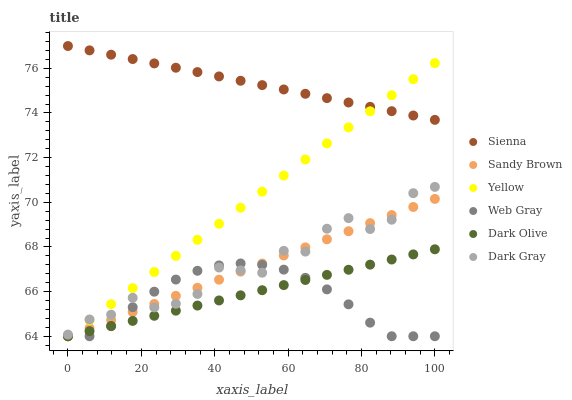Does Web Gray have the minimum area under the curve?
Answer yes or no. Yes. Does Sienna have the maximum area under the curve?
Answer yes or no. Yes. Does Dark Olive have the minimum area under the curve?
Answer yes or no. No. Does Dark Olive have the maximum area under the curve?
Answer yes or no. No. Is Sienna the smoothest?
Answer yes or no. Yes. Is Dark Gray the roughest?
Answer yes or no. Yes. Is Web Gray the smoothest?
Answer yes or no. No. Is Web Gray the roughest?
Answer yes or no. No. Does Web Gray have the lowest value?
Answer yes or no. Yes. Does Sienna have the lowest value?
Answer yes or no. No. Does Sienna have the highest value?
Answer yes or no. Yes. Does Dark Olive have the highest value?
Answer yes or no. No. Is Dark Olive less than Sienna?
Answer yes or no. Yes. Is Dark Gray greater than Dark Olive?
Answer yes or no. Yes. Does Sandy Brown intersect Web Gray?
Answer yes or no. Yes. Is Sandy Brown less than Web Gray?
Answer yes or no. No. Is Sandy Brown greater than Web Gray?
Answer yes or no. No. Does Dark Olive intersect Sienna?
Answer yes or no. No. 